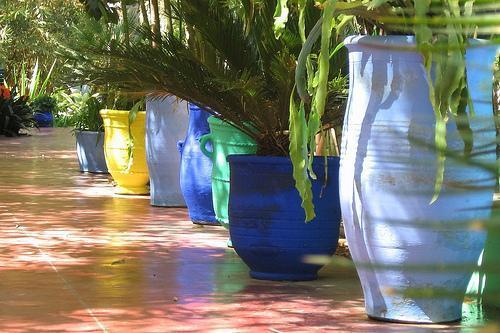How many pots are pictured?
Give a very brief answer. 9. 